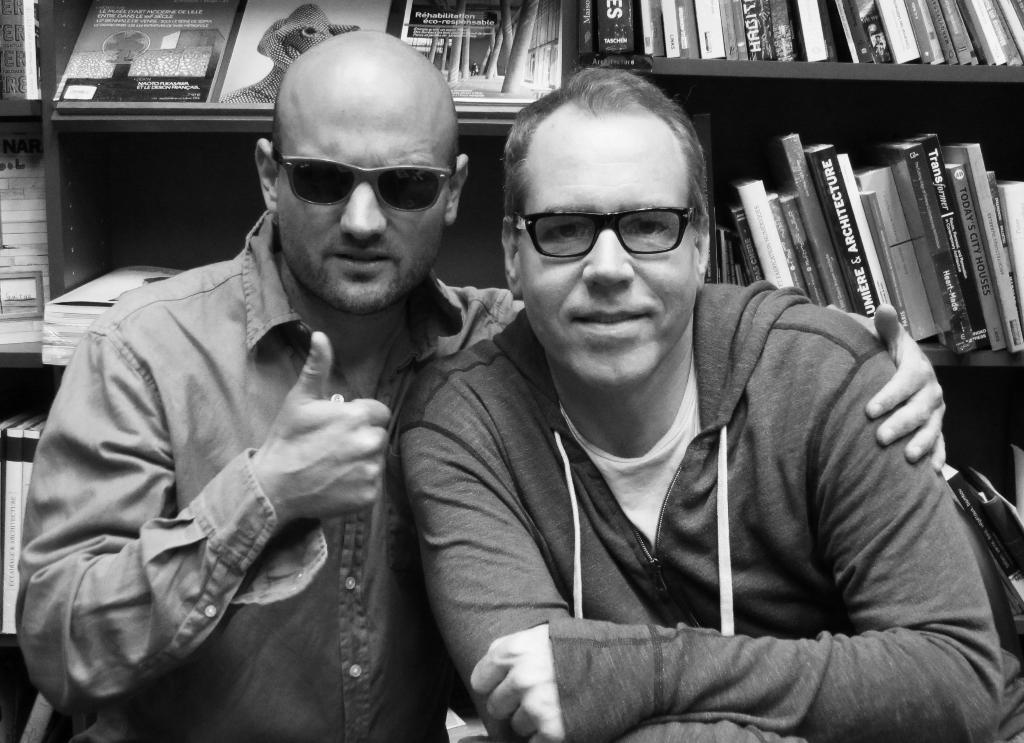How many people are in the image? There are two men in the image. What are the men wearing that is common between them? Both men are wearing spectacles. What can be seen in the background of the image? There is a bookshelf in the background of the image. What is on the bookshelf? The bookshelf contains a number of books. What type of ornament is hanging from the ceiling in the image? There is no ornament hanging from the ceiling in the image. How does the stage look in the image? There is no stage present in the image. 